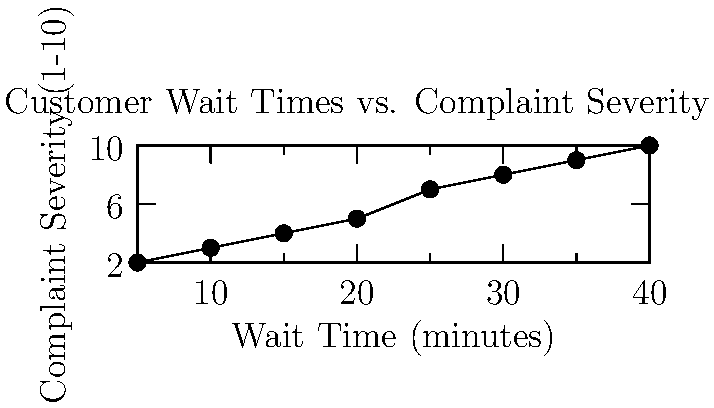Based on the scatter plot of customer wait times versus complaint severity, what is the approximate complaint severity when the wait time is 25 minutes? To answer this question, we need to follow these steps:

1. Locate the x-axis value of 25 minutes on the "Wait Time" axis.
2. Move vertically from this point until we reach the plotted data points.
3. Find the corresponding y-axis value on the "Complaint Severity" axis.

Looking at the scatter plot:

1. We find the 25-minute mark on the x-axis.
2. Moving vertically from this point, we see a data point close to this vertical line.
3. This data point corresponds to a y-axis value of approximately 7 on the "Complaint Severity" scale.

Therefore, when the wait time is 25 minutes, the complaint severity is approximately 7 on a scale of 1-10.
Answer: 7 